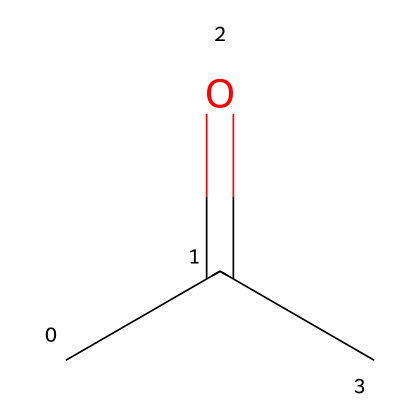How many carbon atoms are in acetone? The structural formula shows three carbon atoms labeled as "C" in the SMILES notation (CC(=O)C).
Answer: three What is the functional group present in acetone? The SMILES representation includes a carbonyl group (C=O), indicating that acetone has a ketone functional group.
Answer: ketone What is the total number of hydrogen atoms in acetone? By analyzing the structure, each carbon forms bonds with hydrogen, resulting in a total of six hydrogen atoms when considering the structure (C3H6O).
Answer: six What type of solvent is acetone? Acetone is a polar solvent, as indicated by its ability to dissolve a variety of substances due to its molecular structure and presence of the carbonyl group.
Answer: polar Which atoms are involved in the carbonyl functional group of acetone? The carbonyl group is composed of one carbon atom (C) and one oxygen atom (O), as derived from the notation (C=O) in the structural formula.
Answer: carbon and oxygen What is the molecular formula of acetone? The molecular formula can be determined from the SMILES representation, which includes three carbon atoms, six hydrogen atoms, and one oxygen atom, giving C3H6O.
Answer: C3H6O 